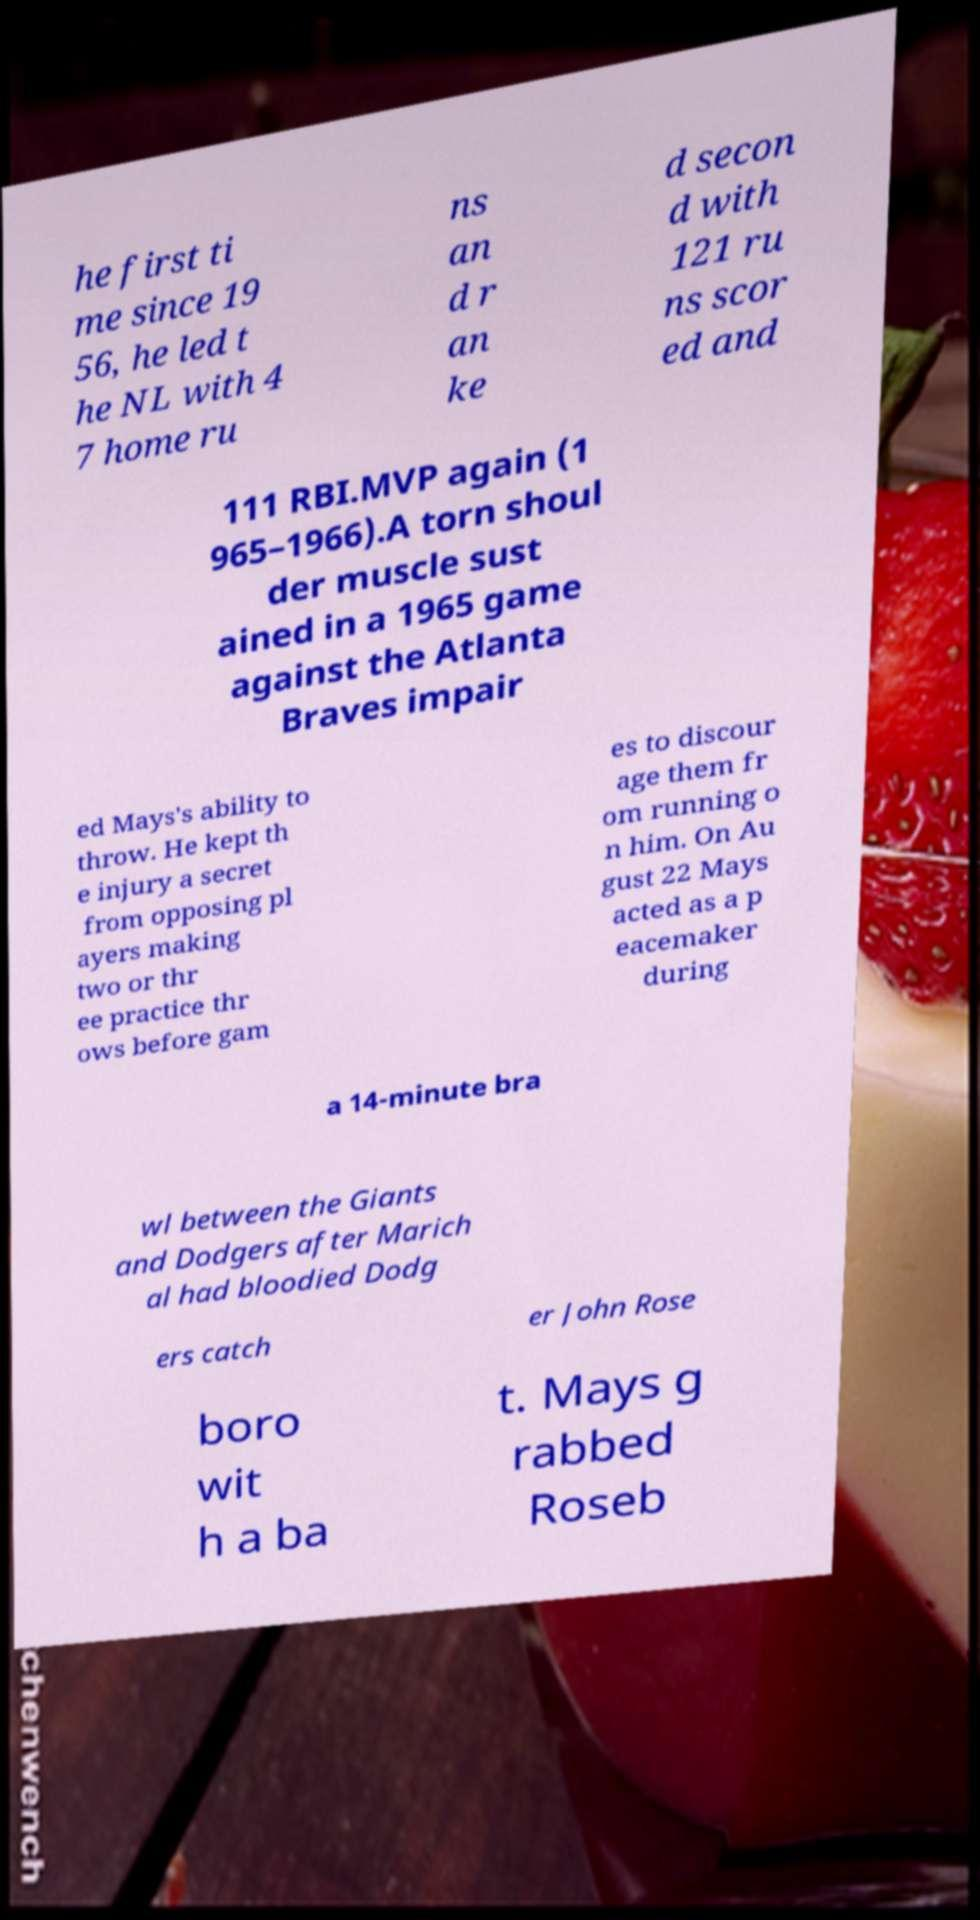Could you extract and type out the text from this image? he first ti me since 19 56, he led t he NL with 4 7 home ru ns an d r an ke d secon d with 121 ru ns scor ed and 111 RBI.MVP again (1 965–1966).A torn shoul der muscle sust ained in a 1965 game against the Atlanta Braves impair ed Mays's ability to throw. He kept th e injury a secret from opposing pl ayers making two or thr ee practice thr ows before gam es to discour age them fr om running o n him. On Au gust 22 Mays acted as a p eacemaker during a 14-minute bra wl between the Giants and Dodgers after Marich al had bloodied Dodg ers catch er John Rose boro wit h a ba t. Mays g rabbed Roseb 